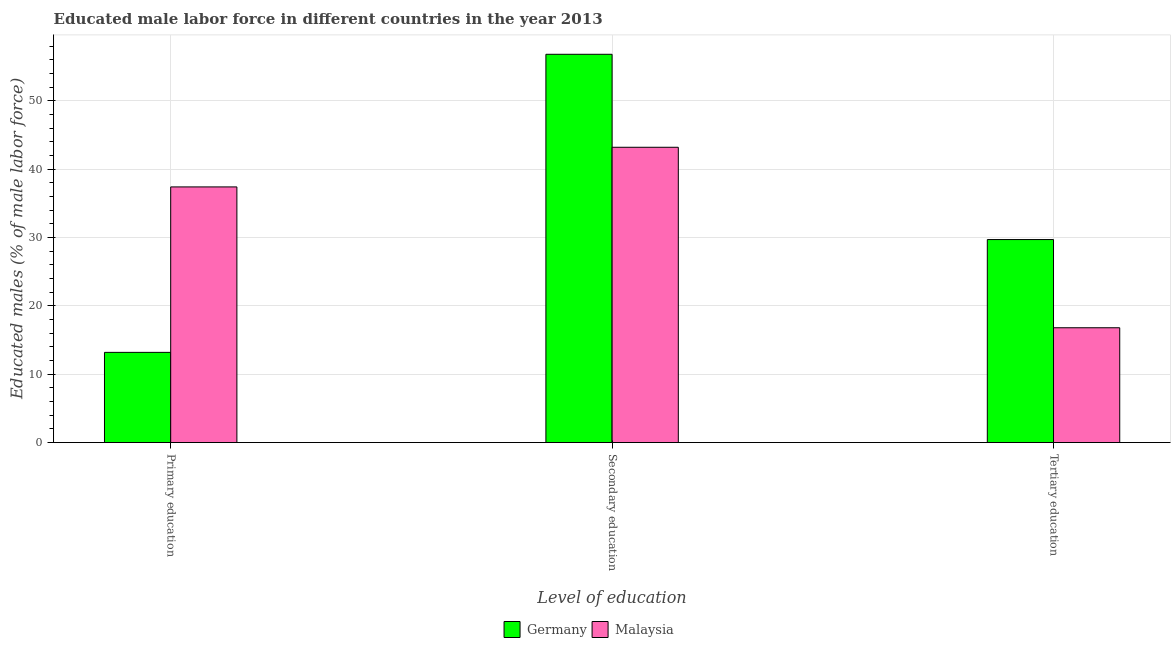How many different coloured bars are there?
Offer a terse response. 2. How many groups of bars are there?
Give a very brief answer. 3. How many bars are there on the 1st tick from the left?
Your response must be concise. 2. How many bars are there on the 3rd tick from the right?
Provide a succinct answer. 2. What is the label of the 3rd group of bars from the left?
Give a very brief answer. Tertiary education. What is the percentage of male labor force who received secondary education in Germany?
Give a very brief answer. 56.8. Across all countries, what is the maximum percentage of male labor force who received secondary education?
Offer a very short reply. 56.8. Across all countries, what is the minimum percentage of male labor force who received secondary education?
Offer a terse response. 43.2. In which country was the percentage of male labor force who received tertiary education maximum?
Keep it short and to the point. Germany. In which country was the percentage of male labor force who received secondary education minimum?
Give a very brief answer. Malaysia. What is the total percentage of male labor force who received tertiary education in the graph?
Provide a short and direct response. 46.5. What is the difference between the percentage of male labor force who received secondary education in Malaysia and that in Germany?
Keep it short and to the point. -13.6. What is the difference between the percentage of male labor force who received secondary education in Malaysia and the percentage of male labor force who received primary education in Germany?
Provide a succinct answer. 30. What is the difference between the percentage of male labor force who received primary education and percentage of male labor force who received secondary education in Malaysia?
Ensure brevity in your answer.  -5.8. In how many countries, is the percentage of male labor force who received primary education greater than 38 %?
Keep it short and to the point. 0. What is the ratio of the percentage of male labor force who received tertiary education in Germany to that in Malaysia?
Make the answer very short. 1.77. Is the percentage of male labor force who received tertiary education in Malaysia less than that in Germany?
Offer a terse response. Yes. Is the difference between the percentage of male labor force who received primary education in Malaysia and Germany greater than the difference between the percentage of male labor force who received tertiary education in Malaysia and Germany?
Make the answer very short. Yes. What is the difference between the highest and the second highest percentage of male labor force who received primary education?
Ensure brevity in your answer.  24.2. What is the difference between the highest and the lowest percentage of male labor force who received tertiary education?
Keep it short and to the point. 12.9. In how many countries, is the percentage of male labor force who received tertiary education greater than the average percentage of male labor force who received tertiary education taken over all countries?
Provide a short and direct response. 1. What does the 1st bar from the left in Tertiary education represents?
Your answer should be compact. Germany. What does the 1st bar from the right in Secondary education represents?
Keep it short and to the point. Malaysia. Is it the case that in every country, the sum of the percentage of male labor force who received primary education and percentage of male labor force who received secondary education is greater than the percentage of male labor force who received tertiary education?
Your answer should be compact. Yes. Are all the bars in the graph horizontal?
Offer a very short reply. No. How many countries are there in the graph?
Provide a short and direct response. 2. What is the difference between two consecutive major ticks on the Y-axis?
Your response must be concise. 10. Are the values on the major ticks of Y-axis written in scientific E-notation?
Offer a terse response. No. Does the graph contain any zero values?
Your answer should be compact. No. Where does the legend appear in the graph?
Provide a succinct answer. Bottom center. How many legend labels are there?
Make the answer very short. 2. What is the title of the graph?
Offer a terse response. Educated male labor force in different countries in the year 2013. What is the label or title of the X-axis?
Your answer should be very brief. Level of education. What is the label or title of the Y-axis?
Ensure brevity in your answer.  Educated males (% of male labor force). What is the Educated males (% of male labor force) in Germany in Primary education?
Provide a succinct answer. 13.2. What is the Educated males (% of male labor force) of Malaysia in Primary education?
Make the answer very short. 37.4. What is the Educated males (% of male labor force) of Germany in Secondary education?
Give a very brief answer. 56.8. What is the Educated males (% of male labor force) in Malaysia in Secondary education?
Ensure brevity in your answer.  43.2. What is the Educated males (% of male labor force) in Germany in Tertiary education?
Offer a terse response. 29.7. What is the Educated males (% of male labor force) in Malaysia in Tertiary education?
Give a very brief answer. 16.8. Across all Level of education, what is the maximum Educated males (% of male labor force) in Germany?
Offer a very short reply. 56.8. Across all Level of education, what is the maximum Educated males (% of male labor force) in Malaysia?
Keep it short and to the point. 43.2. Across all Level of education, what is the minimum Educated males (% of male labor force) of Germany?
Your response must be concise. 13.2. Across all Level of education, what is the minimum Educated males (% of male labor force) of Malaysia?
Make the answer very short. 16.8. What is the total Educated males (% of male labor force) of Germany in the graph?
Your answer should be very brief. 99.7. What is the total Educated males (% of male labor force) in Malaysia in the graph?
Your answer should be very brief. 97.4. What is the difference between the Educated males (% of male labor force) in Germany in Primary education and that in Secondary education?
Provide a succinct answer. -43.6. What is the difference between the Educated males (% of male labor force) in Germany in Primary education and that in Tertiary education?
Ensure brevity in your answer.  -16.5. What is the difference between the Educated males (% of male labor force) of Malaysia in Primary education and that in Tertiary education?
Your response must be concise. 20.6. What is the difference between the Educated males (% of male labor force) of Germany in Secondary education and that in Tertiary education?
Your response must be concise. 27.1. What is the difference between the Educated males (% of male labor force) in Malaysia in Secondary education and that in Tertiary education?
Offer a very short reply. 26.4. What is the difference between the Educated males (% of male labor force) of Germany in Primary education and the Educated males (% of male labor force) of Malaysia in Secondary education?
Your answer should be compact. -30. What is the difference between the Educated males (% of male labor force) of Germany in Secondary education and the Educated males (% of male labor force) of Malaysia in Tertiary education?
Your response must be concise. 40. What is the average Educated males (% of male labor force) of Germany per Level of education?
Provide a succinct answer. 33.23. What is the average Educated males (% of male labor force) in Malaysia per Level of education?
Give a very brief answer. 32.47. What is the difference between the Educated males (% of male labor force) of Germany and Educated males (% of male labor force) of Malaysia in Primary education?
Your answer should be very brief. -24.2. What is the ratio of the Educated males (% of male labor force) in Germany in Primary education to that in Secondary education?
Ensure brevity in your answer.  0.23. What is the ratio of the Educated males (% of male labor force) of Malaysia in Primary education to that in Secondary education?
Your answer should be very brief. 0.87. What is the ratio of the Educated males (% of male labor force) of Germany in Primary education to that in Tertiary education?
Give a very brief answer. 0.44. What is the ratio of the Educated males (% of male labor force) of Malaysia in Primary education to that in Tertiary education?
Your response must be concise. 2.23. What is the ratio of the Educated males (% of male labor force) of Germany in Secondary education to that in Tertiary education?
Provide a short and direct response. 1.91. What is the ratio of the Educated males (% of male labor force) of Malaysia in Secondary education to that in Tertiary education?
Your answer should be compact. 2.57. What is the difference between the highest and the second highest Educated males (% of male labor force) of Germany?
Your answer should be compact. 27.1. What is the difference between the highest and the second highest Educated males (% of male labor force) of Malaysia?
Ensure brevity in your answer.  5.8. What is the difference between the highest and the lowest Educated males (% of male labor force) of Germany?
Provide a succinct answer. 43.6. What is the difference between the highest and the lowest Educated males (% of male labor force) in Malaysia?
Offer a very short reply. 26.4. 